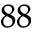Convert formula to latex. <formula><loc_0><loc_0><loc_500><loc_500>^ { 8 8 }</formula> 